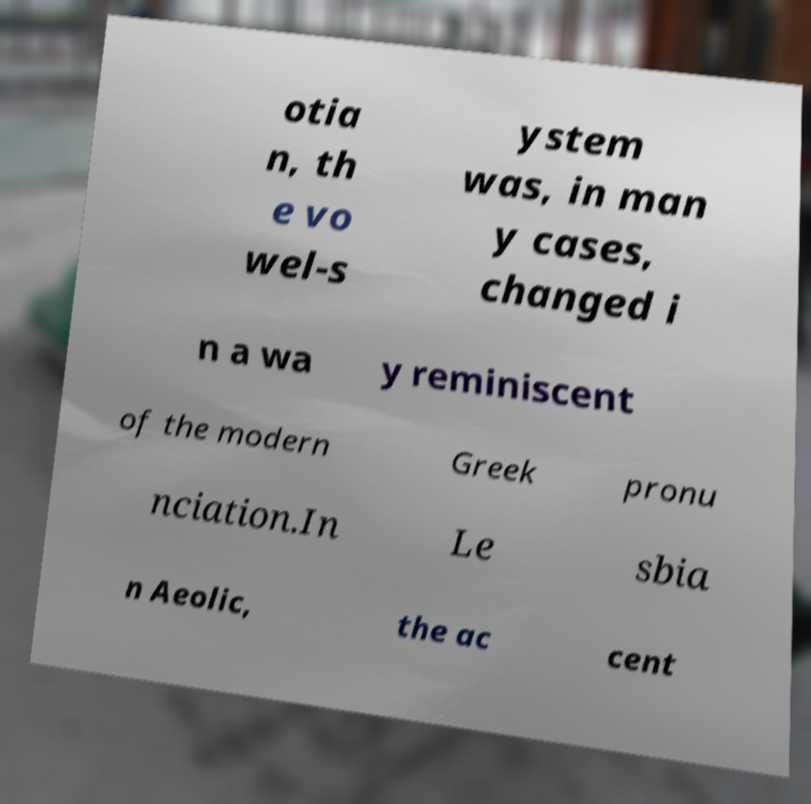Please identify and transcribe the text found in this image. otia n, th e vo wel-s ystem was, in man y cases, changed i n a wa y reminiscent of the modern Greek pronu nciation.In Le sbia n Aeolic, the ac cent 